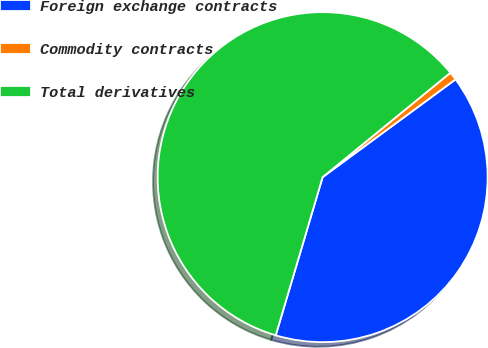Convert chart. <chart><loc_0><loc_0><loc_500><loc_500><pie_chart><fcel>Foreign exchange contracts<fcel>Commodity contracts<fcel>Total derivatives<nl><fcel>39.68%<fcel>0.81%<fcel>59.51%<nl></chart> 